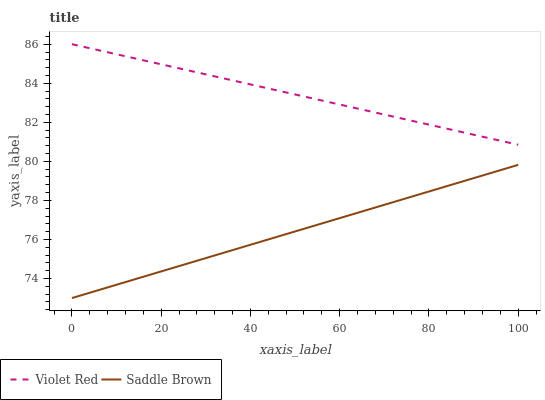Does Saddle Brown have the minimum area under the curve?
Answer yes or no. Yes. Does Violet Red have the maximum area under the curve?
Answer yes or no. Yes. Does Saddle Brown have the maximum area under the curve?
Answer yes or no. No. Is Saddle Brown the smoothest?
Answer yes or no. Yes. Is Violet Red the roughest?
Answer yes or no. Yes. Is Saddle Brown the roughest?
Answer yes or no. No. Does Saddle Brown have the lowest value?
Answer yes or no. Yes. Does Violet Red have the highest value?
Answer yes or no. Yes. Does Saddle Brown have the highest value?
Answer yes or no. No. Is Saddle Brown less than Violet Red?
Answer yes or no. Yes. Is Violet Red greater than Saddle Brown?
Answer yes or no. Yes. Does Saddle Brown intersect Violet Red?
Answer yes or no. No. 